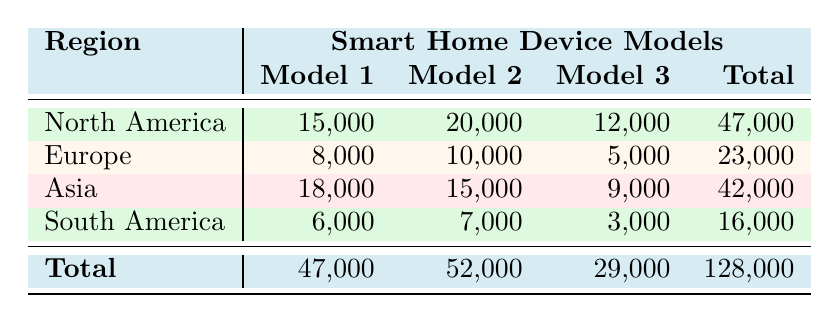What is the total number of units sold for the Amazon Echo in North America? In the table, the "units sold" for the Amazon Echo in North America is listed as 20,000.
Answer: 20,000 Which region has the highest total sales for smart home devices? To find the region with the highest total sales, we compare the total units sold for each region: North America (47,000), Europe (23,000), Asia (42,000), and South America (16,000). North America has the highest total.
Answer: North America What is the total number of units sold for all models in South America? The total units sold in South America can be found by adding the units sold for each model: 6,000 (Google Nest Hub) + 7,000 (Amazon Echo Dot) + 3,000 (Philips Hue) = 16,000.
Answer: 16,000 Is the total units sold for the Philips Hue greater than the total units sold for the Samsung SmartThings? The total for Philips Hue is 10,000 (Europe) + 3,000 (South America) = 13,000. The total for Samsung SmartThings is 9,000 (Asia). Since 13,000 is greater than 9,000, the statement is true.
Answer: Yes What is the average number of units sold per model in North America? The total units sold in North America is 47,000 across three models. To find the average, divide 47,000 by 3, resulting in approximately 15,667.
Answer: 15,667 What is the percentage of total units sold for the Xiaomi Mi Smart Home Hub out of the overall total units sold? The total units sold for the Xiaomi Mi Smart Home Hub is 18,000. The overall total units sold across all regions and models is 128,000. To calculate the percentage: (18,000 / 128,000) * 100 = 14.06%.
Answer: 14.06% Which model sold the least units in Europe? In Europe, the models and their units sold are: Netatmo Weather Station (8,000), Philips Hue (10,000), and Apple HomePod (5,000). The Apple HomePod has the least units sold, at 5,000.
Answer: Apple HomePod By how much are the total sales in Asia less than the total sales in North America? The total sales in Asia is 42,000, and North America has 47,000. To find the difference: 47,000 - 42,000 = 5,000, so total sales in Asia are less by 5,000.
Answer: 5,000 